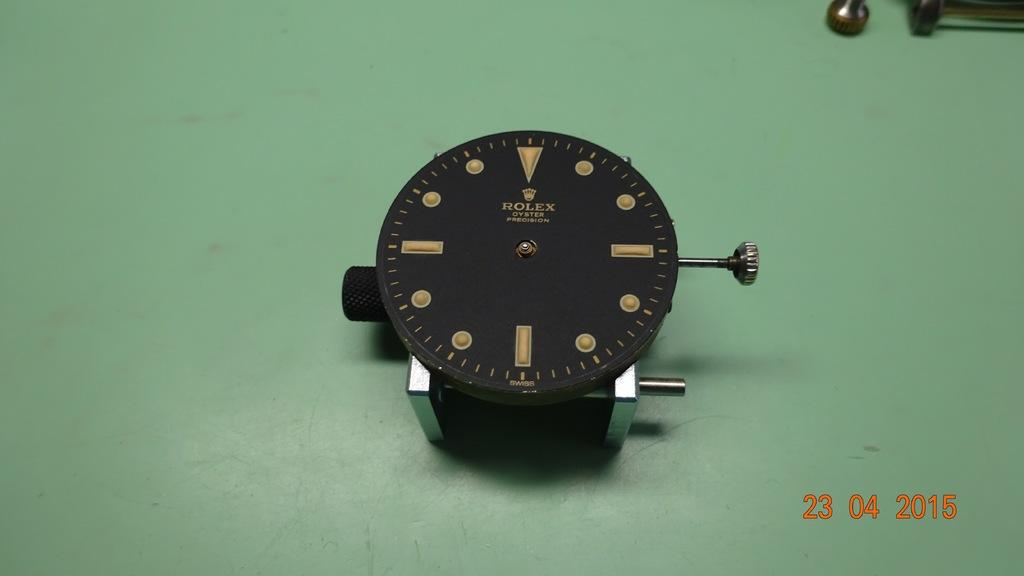Provide a one-sentence caption for the provided image. A Rolex oyster watch face is sitting on a table. 